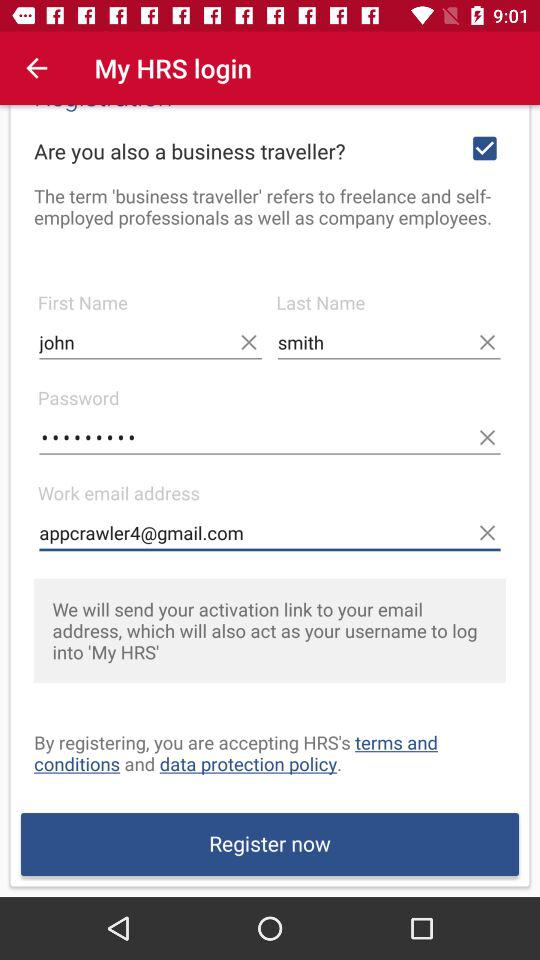How many text inputs are there for the user to fill out?
Answer the question using a single word or phrase. 4 